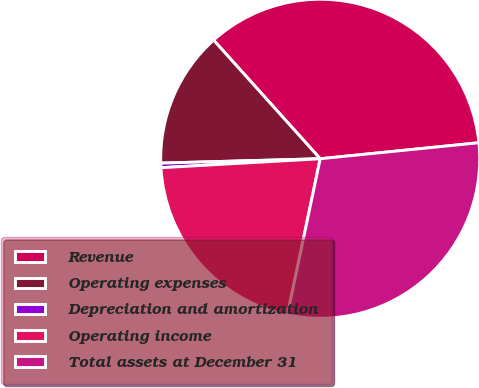Convert chart to OTSL. <chart><loc_0><loc_0><loc_500><loc_500><pie_chart><fcel>Revenue<fcel>Operating expenses<fcel>Depreciation and amortization<fcel>Operating income<fcel>Total assets at December 31<nl><fcel>35.05%<fcel>13.78%<fcel>0.46%<fcel>20.81%<fcel>29.89%<nl></chart> 